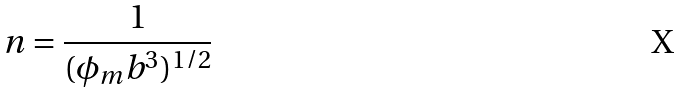<formula> <loc_0><loc_0><loc_500><loc_500>n = \frac { 1 } { ( \phi _ { m } b ^ { 3 } ) ^ { 1 / 2 } }</formula> 